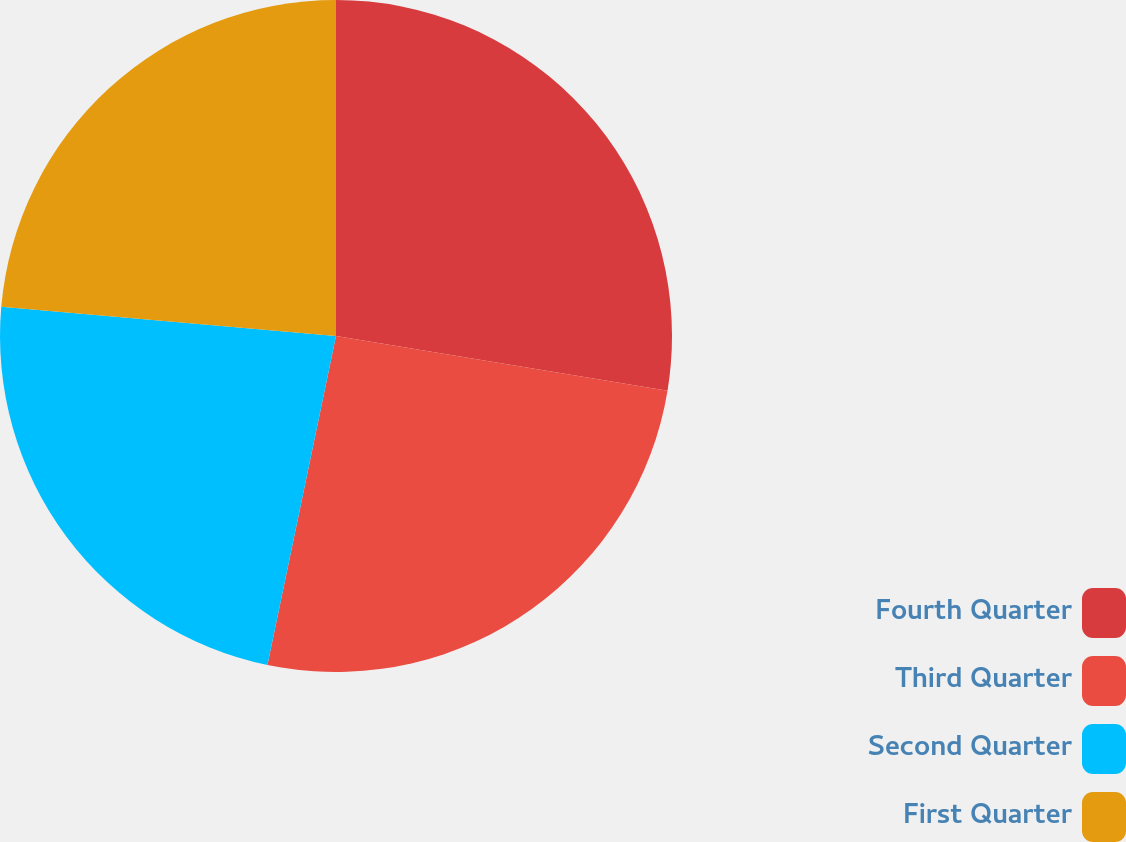<chart> <loc_0><loc_0><loc_500><loc_500><pie_chart><fcel>Fourth Quarter<fcel>Third Quarter<fcel>Second Quarter<fcel>First Quarter<nl><fcel>27.6%<fcel>25.67%<fcel>23.12%<fcel>23.61%<nl></chart> 